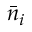Convert formula to latex. <formula><loc_0><loc_0><loc_500><loc_500>\bar { n } _ { i }</formula> 